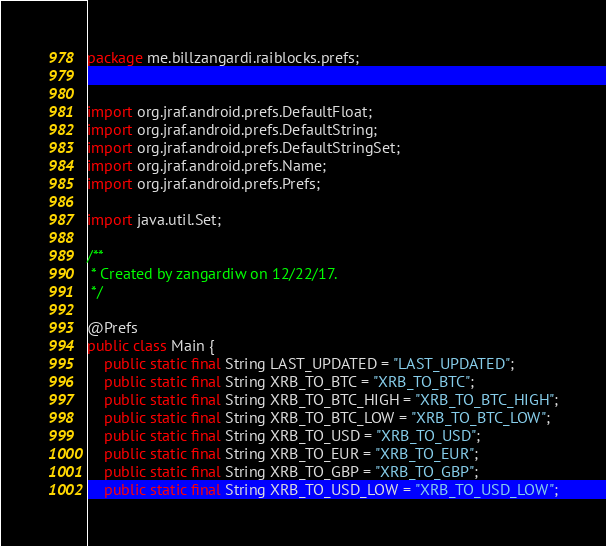Convert code to text. <code><loc_0><loc_0><loc_500><loc_500><_Java_>package me.billzangardi.raiblocks.prefs;


import org.jraf.android.prefs.DefaultFloat;
import org.jraf.android.prefs.DefaultString;
import org.jraf.android.prefs.DefaultStringSet;
import org.jraf.android.prefs.Name;
import org.jraf.android.prefs.Prefs;

import java.util.Set;

/**
 * Created by zangardiw on 12/22/17.
 */

@Prefs
public class Main {
    public static final String LAST_UPDATED = "LAST_UPDATED";
    public static final String XRB_TO_BTC = "XRB_TO_BTC";
    public static final String XRB_TO_BTC_HIGH = "XRB_TO_BTC_HIGH";
    public static final String XRB_TO_BTC_LOW = "XRB_TO_BTC_LOW";
    public static final String XRB_TO_USD = "XRB_TO_USD";
    public static final String XRB_TO_EUR = "XRB_TO_EUR";
    public static final String XRB_TO_GBP = "XRB_TO_GBP";
    public static final String XRB_TO_USD_LOW = "XRB_TO_USD_LOW";</code> 